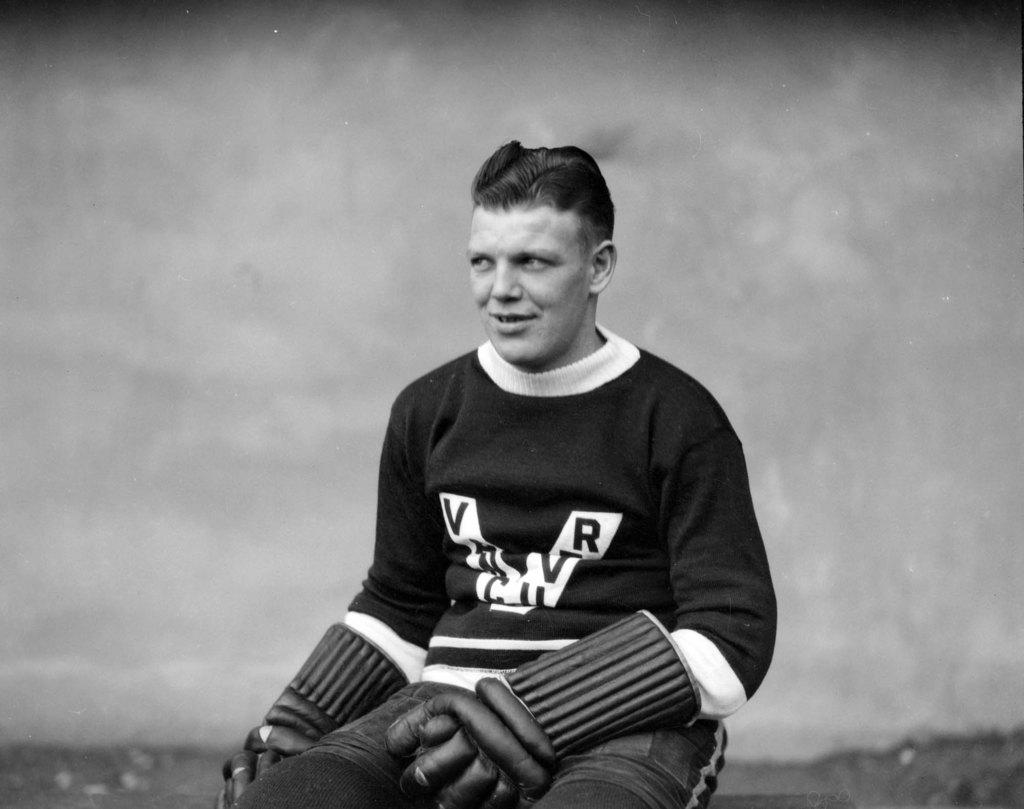Who or what is present in the image? There is a person in the image. What is the person doing in the image? The person is sitting on the floor. What is the person wearing on their hands? The person is wearing gloves. What type of scent can be detected from the person in the image? There is no information about the scent of the person in the image, so it cannot be determined. 